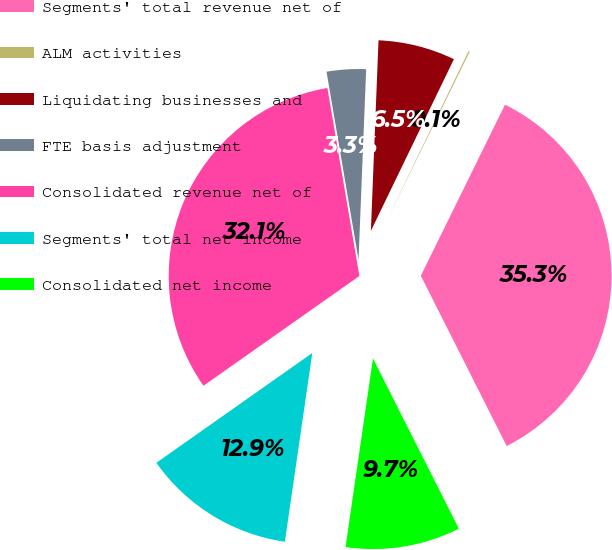<chart> <loc_0><loc_0><loc_500><loc_500><pie_chart><fcel>Segments' total revenue net of<fcel>ALM activities<fcel>Liquidating businesses and<fcel>FTE basis adjustment<fcel>Consolidated revenue net of<fcel>Segments' total net income<fcel>Consolidated net income<nl><fcel>35.29%<fcel>0.11%<fcel>6.53%<fcel>3.32%<fcel>32.08%<fcel>12.94%<fcel>9.73%<nl></chart> 